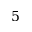<formula> <loc_0><loc_0><loc_500><loc_500>5</formula> 